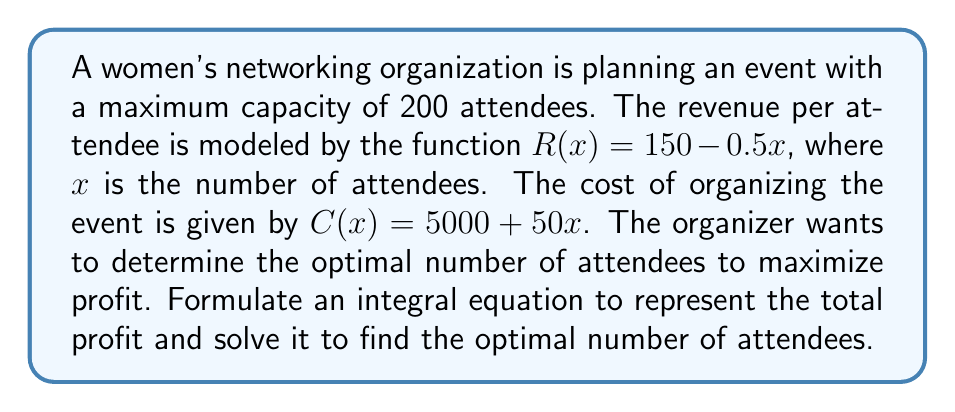Help me with this question. 1) First, let's define the profit function $P(x)$ as the difference between revenue and cost:

   $P(x) = R(x) - C(x) = (150 - 0.5x) - (5000 + 50x) = 150 - 0.5x - 5000 - 50x = -50.5x - 4850$

2) To find the total profit, we need to integrate the profit function over the number of attendees:

   $$\int_0^x P(t) dt = \int_0^x (-50.5t - 4850) dt$$

3) Solving this integral:

   $$\int_0^x P(t) dt = [-25.25t^2 - 4850t]_0^x = -25.25x^2 - 4850x$$

4) To find the optimal number of attendees, we need to find the maximum of this function. We can do this by differentiating and setting it to zero:

   $$\frac{d}{dx}(-25.25x^2 - 4850x) = -50.5x - 4850 = 0$$

5) Solving this equation:

   $-50.5x = 4850$
   $x = 96.04$

6) Since we can't have a fractional number of attendees, we round this to 96.

7) To confirm this is a maximum (not a minimum), we can check the second derivative:

   $$\frac{d^2}{dx^2}(-25.25x^2 - 4850x) = -50.5$$

   This is negative, confirming we have found a maximum.
Answer: 96 attendees 